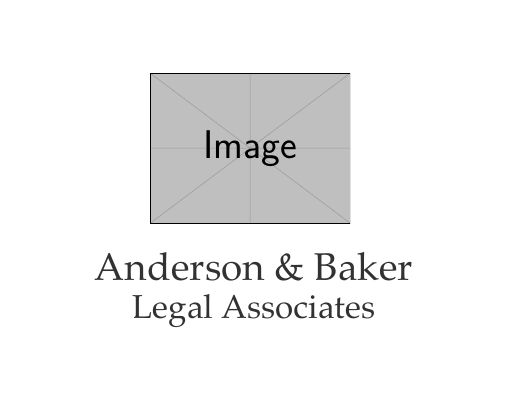what is the name of the firm? The firm’s name is prominently displayed in a serif font, which is Anderson & Baker.
Answer: Anderson & Baker what is the office address? The office address includes the specific number, street, suite, city, state, and postal code. It is 123 Justice Avenue, Suite 456, New York, NY 10001.
Answer: 123 Justice Avenue, Suite 456, New York, NY 10001 what is the phone number? The phone number is shown clearly on the card. It is (212) 555-7890.
Answer: (212) 555-7890 what is the email address? The email is listed in a standard format for easy communication. It is contact@anderson-baker.com.
Answer: contact@anderson-baker.com what are the core services offered by the firm? The services are presented with icons and text; they include Corporate Law, Family Law, Real Estate Law, Criminal Defense, and Personal Injury.
Answer: Corporate Law, Family Law, Real Estate Law, Criminal Defense, Personal Injury how many legal services are listed on the card? By counting each service listed under "Our Services," we see that there are five in total.
Answer: 5 what type of services does the firm specialize in? The firm's services fall within legal categories, specifically covering various areas of law as listed.
Answer: Legal Services in what format is the firm’s name displayed? The firm’s name is displayed using an elegant serif font, which adds to its professional appearance.
Answer: Serif font 